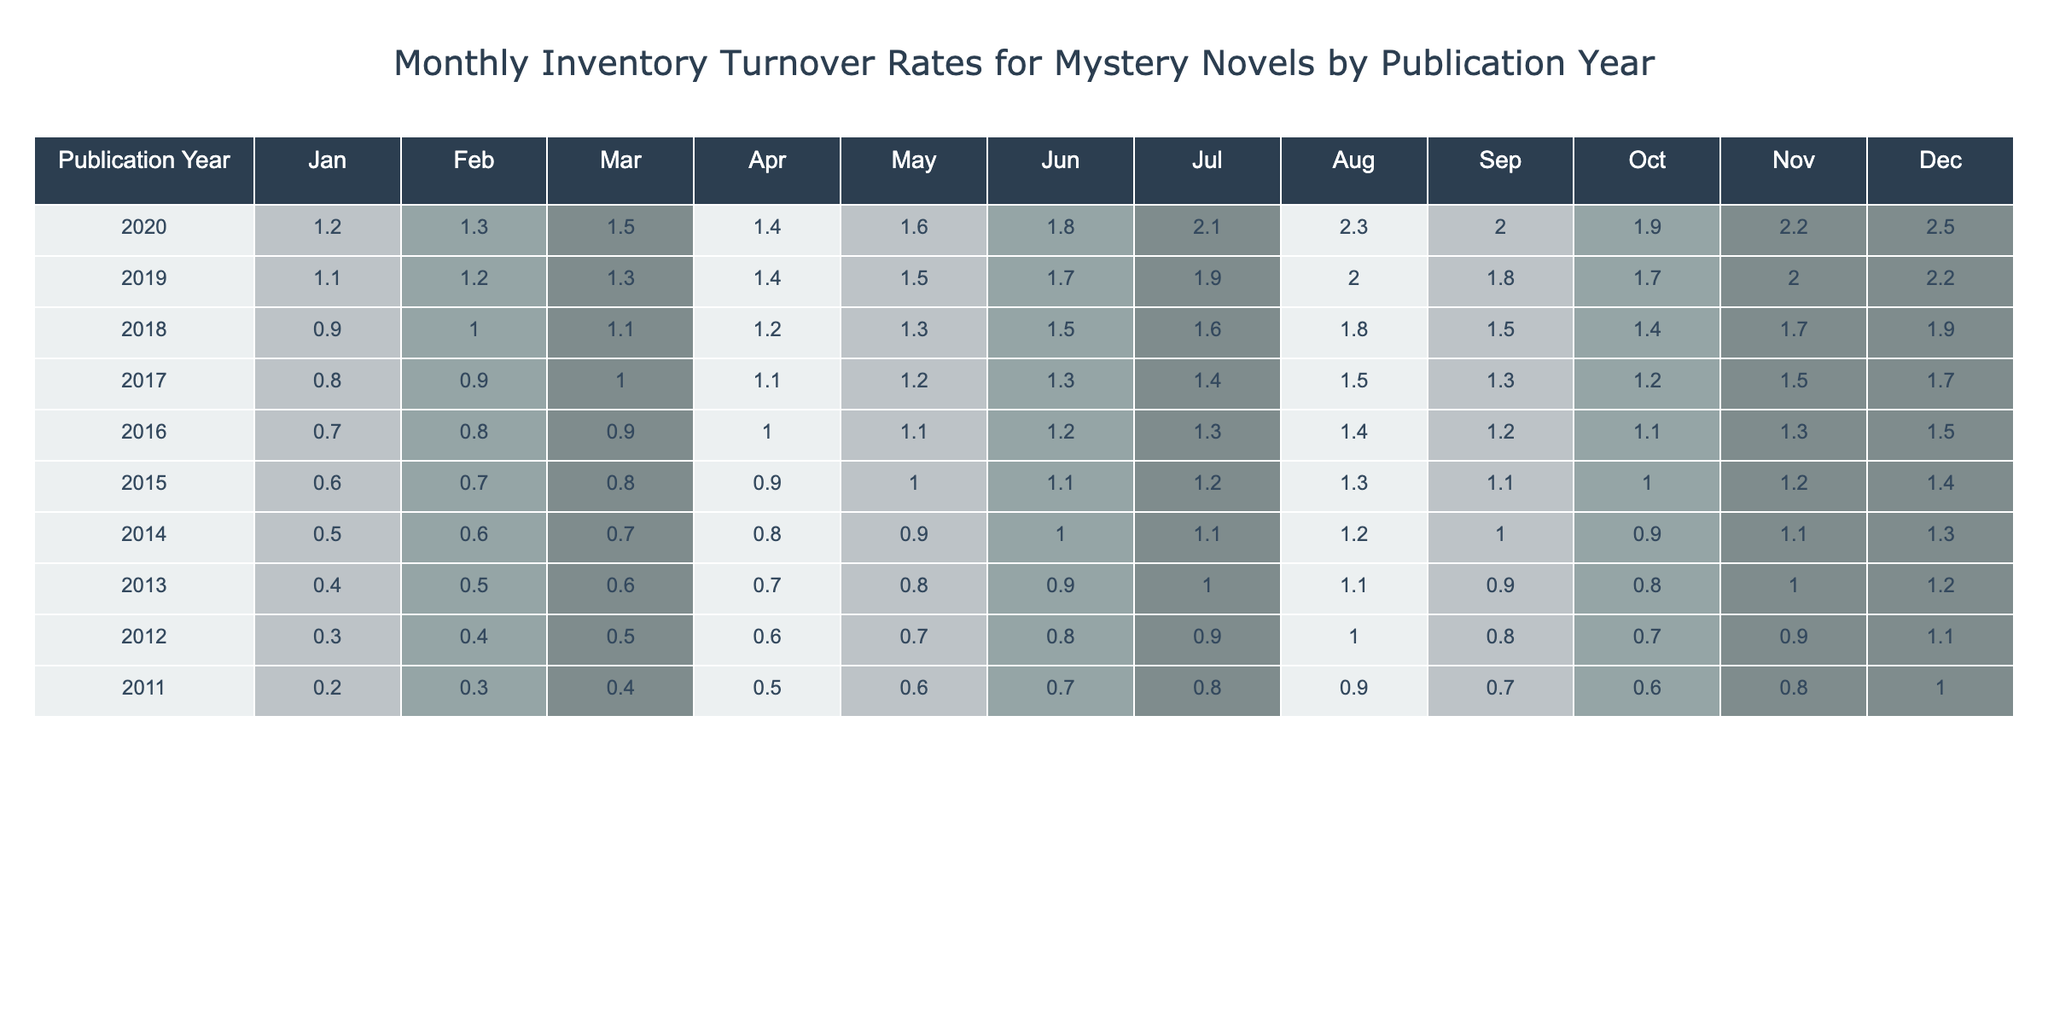What was the turnover rate for mystery novels published in 2020 in December? The table shows that the turnover rate for the year 2020 in December is 2.5.
Answer: 2.5 Which month had the highest turnover rate for novels published in 2019? Analyzing the row for 2019, the turnover rate peaked in December at 2.2.
Answer: 2.2 What is the average turnover rate for mystery novels published in 2018? The turnover rates for 2018 are: 0.9, 1.0, 1.1, 1.2, 1.3, 1.5, 1.6, 1.8, 1.5, 1.4, 1.7, 1.9. Summing these values gives 16.6, and dividing by 12 results in an average of approximately 1.38.
Answer: 1.38 Did the turnover rate for novels published in 2013 increase or decrease from January to December? The turnover rate for January 2013 is 0.4 while in December it is 1.2. Since 1.2 is greater than 0.4, the turnover rate increased throughout the year.
Answer: Increase What is the difference in turnover rates between the highest month for novels published in 2020 and that for novels published in 2015? The highest turnover rate for 2020 is 2.5 in December, and for 2015, it is 1.4 in December. The difference is 2.5 - 1.4 = 1.1.
Answer: 1.1 Which publication year had the overall highest average monthly turnover rate? Calculating the average rates for each year, 2020 has the highest average turnover rate of approximately 1.93.
Answer: 2020 Are there any months where the turnover rate for novels published in 2016 was higher than 1.5? In the table, the rates show that 2016 had values only reaching up to 1.5 in December. Therefore, there are no months where it exceeded 1.5.
Answer: No What was the trend in turnover rates from 2011 to 2020? Examining the values, there is a clear upward trend in turnover rates as the years progress from 0.2 in 2011 to 2.5 in 2020.
Answer: Upward trend How does the average turnover rate from 2014 compare to that of 2019? The average turnover rate for 2014 is (0.5 + 0.6 + 0.7 + 0.8 + 0.9 + 1.0 + 1.1 + 1.2 + 1.0 + 0.9 + 1.1 + 1.3) / 12 = 0.88. For 2019, it is (1.1 + 1.2 + 1.3 + 1.4 + 1.5 + 1.7 + 1.9 + 2.0 + 1.8 + 1.7 + 2.0 + 2.2) / 12 ≈ 1.57. Since 1.57 is greater than 0.88, 2019's average is higher.
Answer: 2019's average is higher Which year had the lowest turnover rate in June? Searching through the data, 2011 had the lowest turnover rate of 0.7 in June.
Answer: 2011 